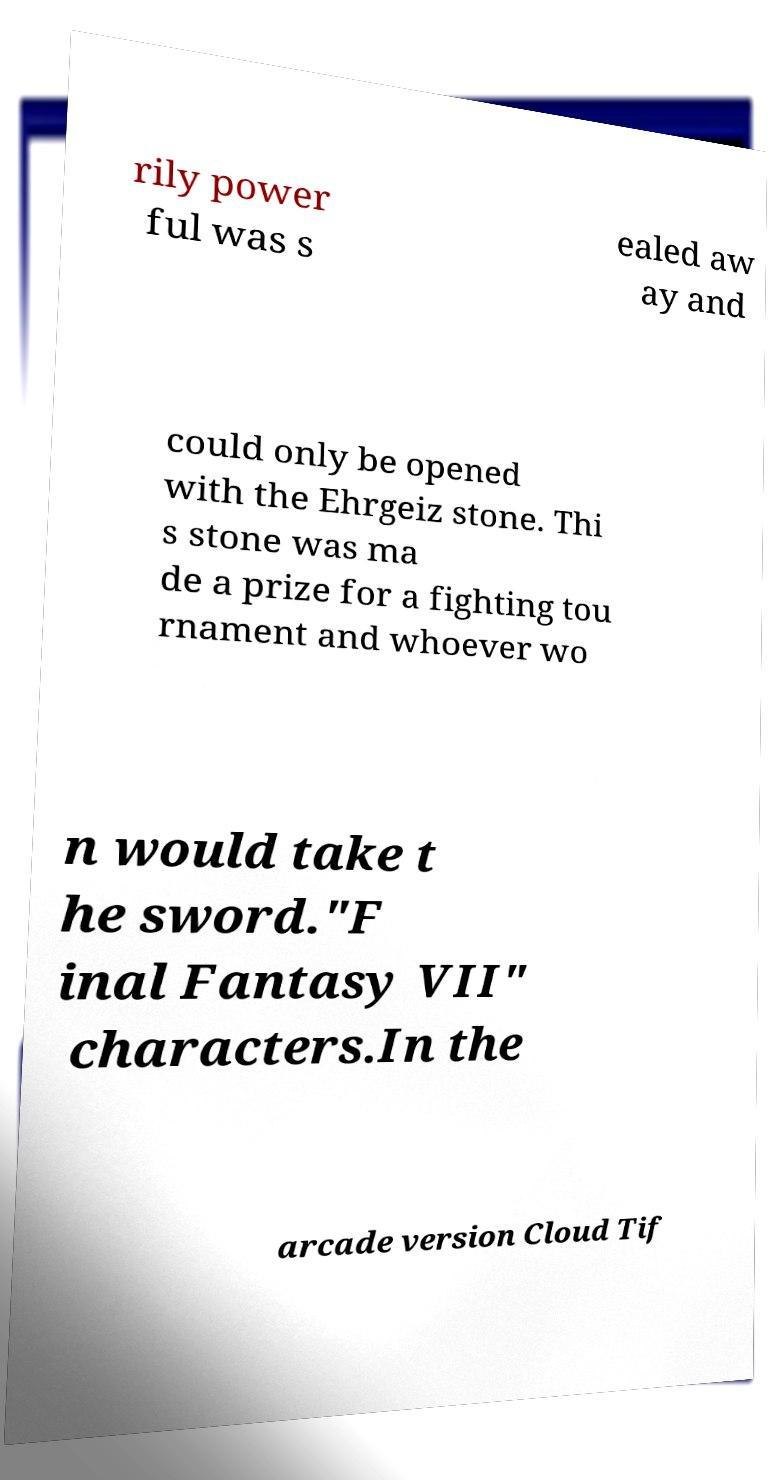Please identify and transcribe the text found in this image. rily power ful was s ealed aw ay and could only be opened with the Ehrgeiz stone. Thi s stone was ma de a prize for a fighting tou rnament and whoever wo n would take t he sword."F inal Fantasy VII" characters.In the arcade version Cloud Tif 